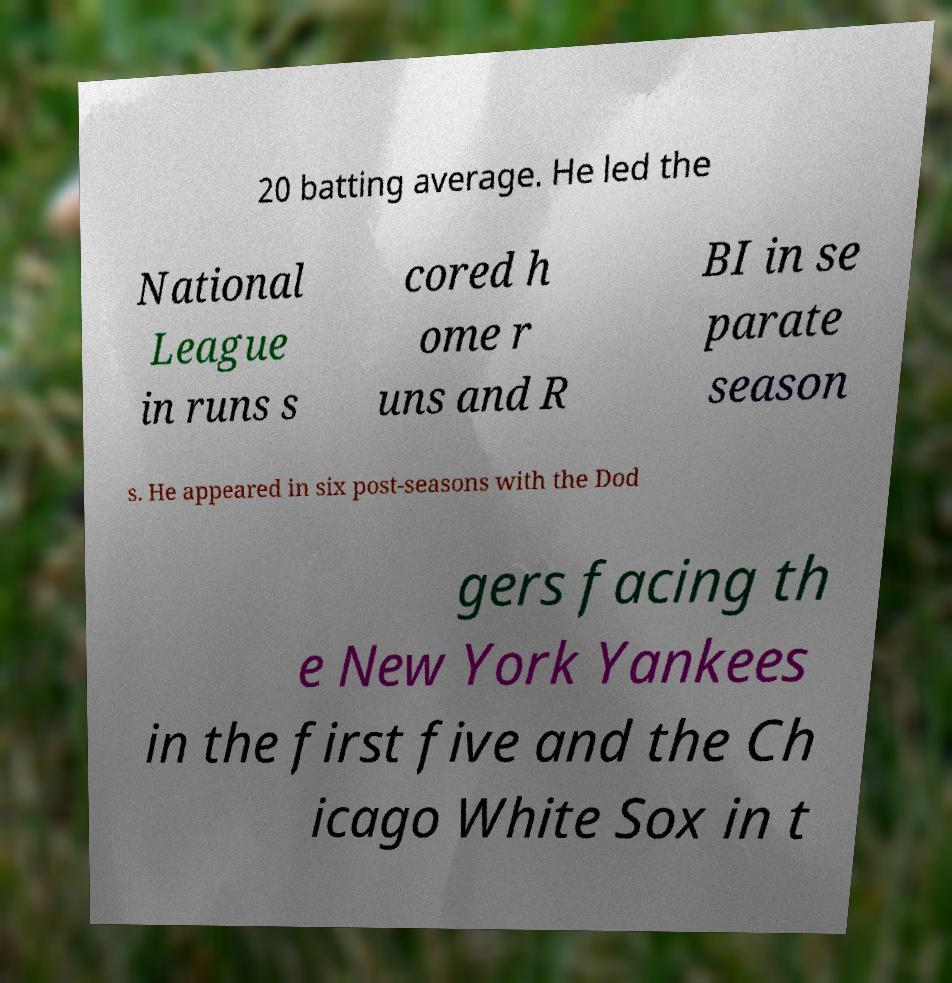For documentation purposes, I need the text within this image transcribed. Could you provide that? 20 batting average. He led the National League in runs s cored h ome r uns and R BI in se parate season s. He appeared in six post-seasons with the Dod gers facing th e New York Yankees in the first five and the Ch icago White Sox in t 